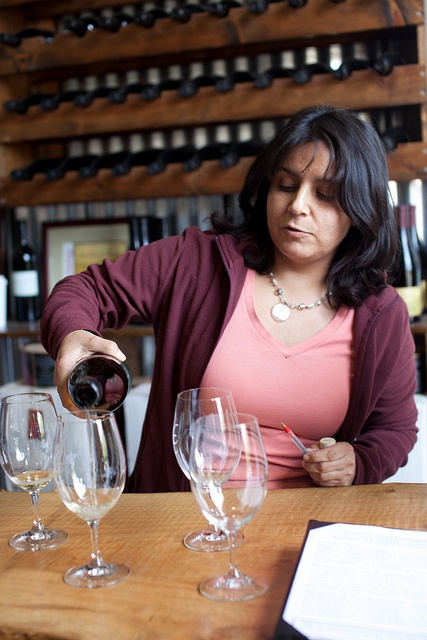Describe the objects in this image and their specific colors. I can see people in black, maroon, lightpink, and purple tones, dining table in black, tan, white, and salmon tones, wine glass in black, lightpink, lightgray, darkgray, and salmon tones, wine glass in black, darkgray, lightgray, and gray tones, and wine glass in black, darkgray, tan, and gray tones in this image. 